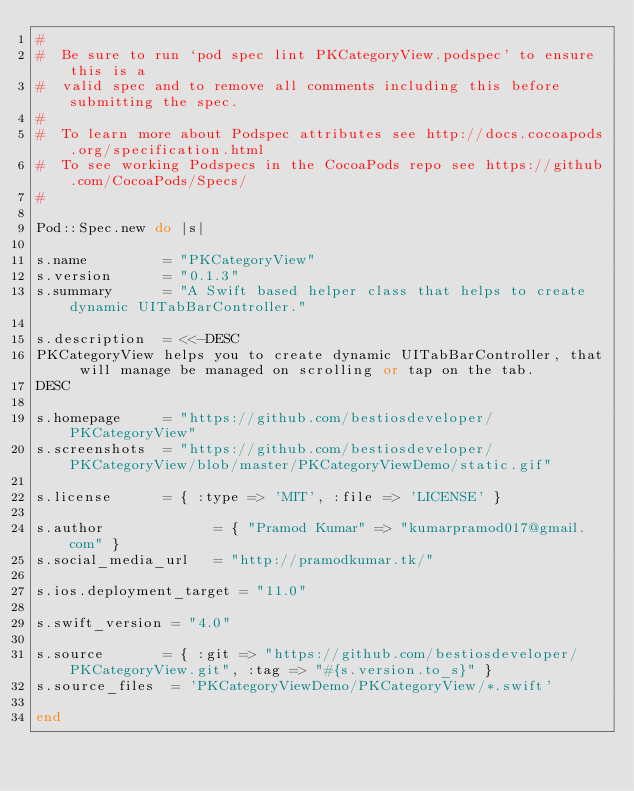Convert code to text. <code><loc_0><loc_0><loc_500><loc_500><_Ruby_>#
#  Be sure to run `pod spec lint PKCategoryView.podspec' to ensure this is a
#  valid spec and to remove all comments including this before submitting the spec.
#
#  To learn more about Podspec attributes see http://docs.cocoapods.org/specification.html
#  To see working Podspecs in the CocoaPods repo see https://github.com/CocoaPods/Specs/
#

Pod::Spec.new do |s|

s.name         = "PKCategoryView"
s.version      = "0.1.3"
s.summary      = "A Swift based helper class that helps to create dynamic UITabBarController."

s.description  = <<-DESC
PKCategoryView helps you to create dynamic UITabBarController, that will manage be managed on scrolling or tap on the tab.
DESC

s.homepage     = "https://github.com/bestiosdeveloper/PKCategoryView"
s.screenshots  = "https://github.com/bestiosdeveloper/PKCategoryView/blob/master/PKCategoryViewDemo/static.gif"

s.license      = { :type => 'MIT', :file => 'LICENSE' }

s.author             = { "Pramod Kumar" => "kumarpramod017@gmail.com" }
s.social_media_url   = "http://pramodkumar.tk/"

s.ios.deployment_target = "11.0"

s.swift_version = "4.0"

s.source       = { :git => "https://github.com/bestiosdeveloper/PKCategoryView.git", :tag => "#{s.version.to_s}" }
s.source_files  = 'PKCategoryViewDemo/PKCategoryView/*.swift'

end

</code> 